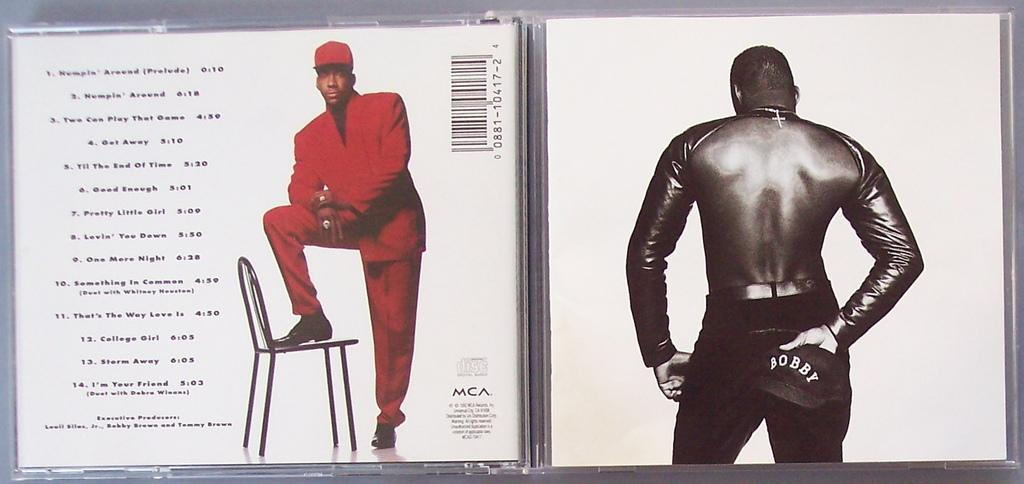What is located on the left side of the image? There is a person and a chair on the left side of the image, along with some texts. What is the person on the right side of the image holding? The person on the right side is holding a cap. Can you describe the texts on the left side of the image? Unfortunately, the provided facts do not give any information about the content or appearance of the texts. What is the agreement rate between the two people in the image? There is no information about any agreement or rate in the image, as it only shows two people and a cap. How does the heat affect the person on the left side of the image? There is no information about heat or temperature in the image, so we cannot determine its effect on the person. 